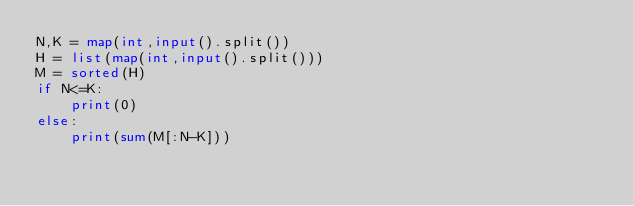<code> <loc_0><loc_0><loc_500><loc_500><_Python_>N,K = map(int,input().split())
H = list(map(int,input().split()))
M = sorted(H)
if N<=K:
    print(0)
else:
    print(sum(M[:N-K]))
</code> 